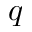<formula> <loc_0><loc_0><loc_500><loc_500>q</formula> 